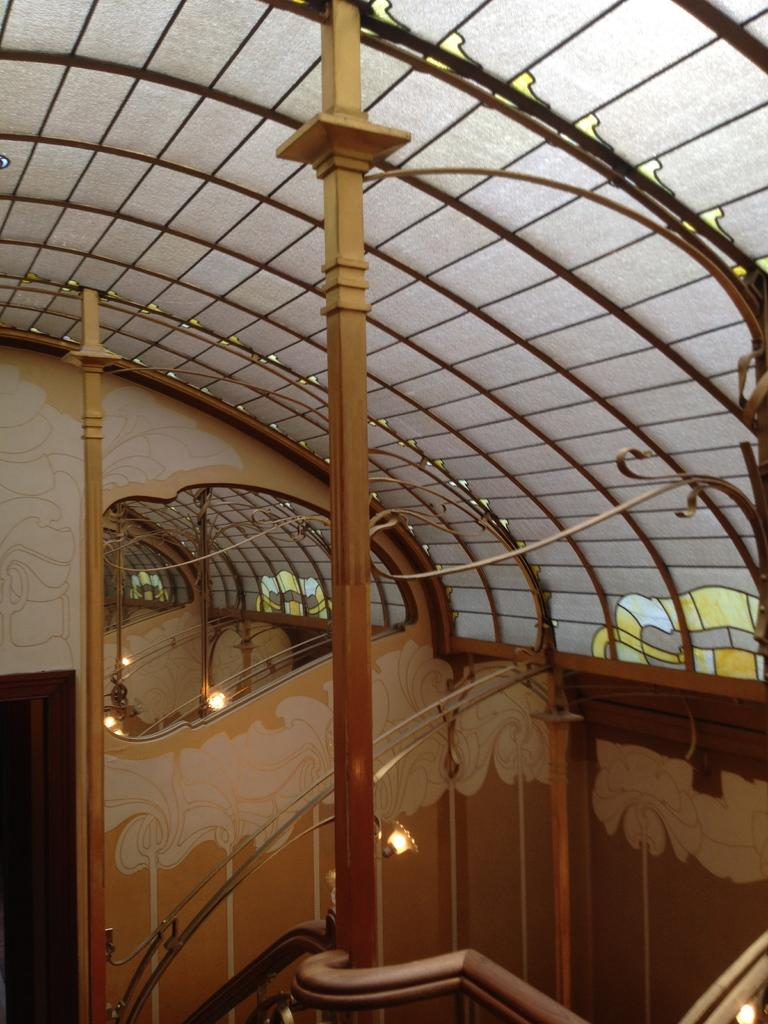What type of view is depicted in the image? The image shows an inner view of a building. What type of spoon can be seen hanging from the arch in the image? There is no spoon or arch present in the image; it only shows an inner view of a building. 